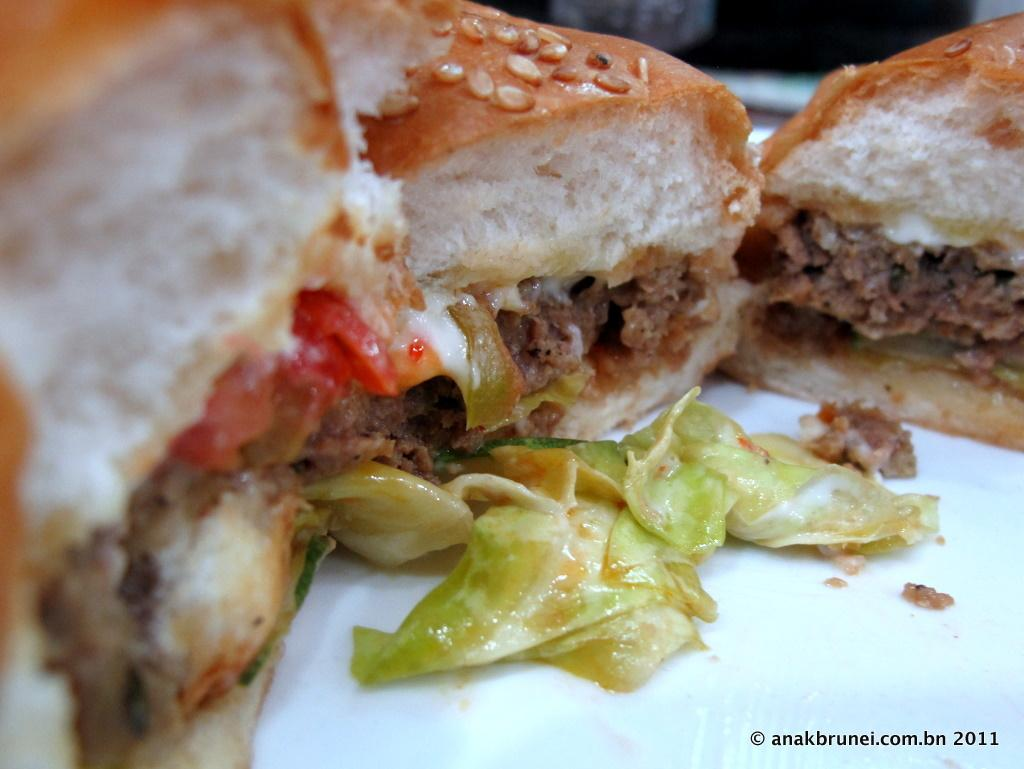What type of food is visible in the image? There are burgers in the image. What type of scarf is draped over the burgers in the image? There is no scarf present in the image; it features burgers only. What type of mint can be seen growing near the burgers in the image? There is no mint present in the image; it features burgers only. 